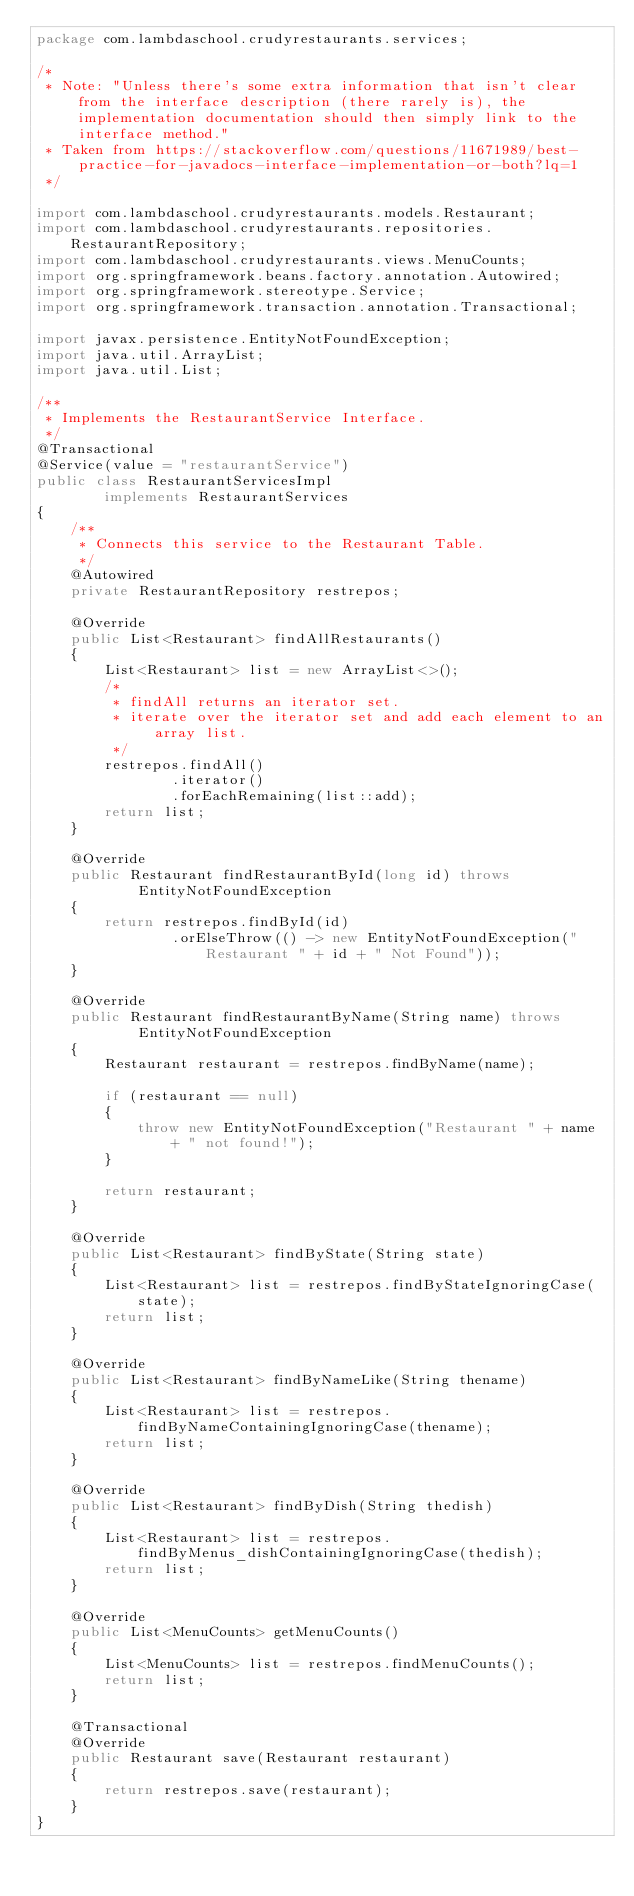Convert code to text. <code><loc_0><loc_0><loc_500><loc_500><_Java_>package com.lambdaschool.crudyrestaurants.services;

/*
 * Note: "Unless there's some extra information that isn't clear from the interface description (there rarely is), the implementation documentation should then simply link to the interface method."
 * Taken from https://stackoverflow.com/questions/11671989/best-practice-for-javadocs-interface-implementation-or-both?lq=1
 */

import com.lambdaschool.crudyrestaurants.models.Restaurant;
import com.lambdaschool.crudyrestaurants.repositories.RestaurantRepository;
import com.lambdaschool.crudyrestaurants.views.MenuCounts;
import org.springframework.beans.factory.annotation.Autowired;
import org.springframework.stereotype.Service;
import org.springframework.transaction.annotation.Transactional;

import javax.persistence.EntityNotFoundException;
import java.util.ArrayList;
import java.util.List;

/**
 * Implements the RestaurantService Interface.
 */
@Transactional
@Service(value = "restaurantService")
public class RestaurantServicesImpl
        implements RestaurantServices
{
    /**
     * Connects this service to the Restaurant Table.
     */
    @Autowired
    private RestaurantRepository restrepos;

    @Override
    public List<Restaurant> findAllRestaurants()
    {
        List<Restaurant> list = new ArrayList<>();
        /*
         * findAll returns an iterator set.
         * iterate over the iterator set and add each element to an array list.
         */
        restrepos.findAll()
                .iterator()
                .forEachRemaining(list::add);
        return list;
    }

    @Override
    public Restaurant findRestaurantById(long id) throws
            EntityNotFoundException
    {
        return restrepos.findById(id)
                .orElseThrow(() -> new EntityNotFoundException("Restaurant " + id + " Not Found"));
    }

    @Override
    public Restaurant findRestaurantByName(String name) throws
            EntityNotFoundException
    {
        Restaurant restaurant = restrepos.findByName(name);

        if (restaurant == null)
        {
            throw new EntityNotFoundException("Restaurant " + name + " not found!");
        }

        return restaurant;
    }

    @Override
    public List<Restaurant> findByState(String state)
    {
        List<Restaurant> list = restrepos.findByStateIgnoringCase(state);
        return list;
    }

    @Override
    public List<Restaurant> findByNameLike(String thename)
    {
        List<Restaurant> list = restrepos.findByNameContainingIgnoringCase(thename);
        return list;
    }

    @Override
    public List<Restaurant> findByDish(String thedish)
    {
        List<Restaurant> list = restrepos.findByMenus_dishContainingIgnoringCase(thedish);
        return list;
    }

    @Override
    public List<MenuCounts> getMenuCounts()
    {
        List<MenuCounts> list = restrepos.findMenuCounts();
        return list;
    }

    @Transactional
    @Override
    public Restaurant save(Restaurant restaurant)
    {
        return restrepos.save(restaurant);
    }
}
</code> 